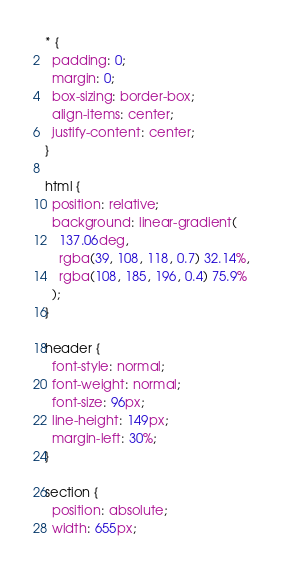Convert code to text. <code><loc_0><loc_0><loc_500><loc_500><_CSS_>* {
  padding: 0;
  margin: 0;
  box-sizing: border-box;
  align-items: center;
  justify-content: center;
}

html {
  position: relative;
  background: linear-gradient(
    137.06deg,
    rgba(39, 108, 118, 0.7) 32.14%,
    rgba(108, 185, 196, 0.4) 75.9%
  );
}

header {
  font-style: normal;
  font-weight: normal;
  font-size: 96px;
  line-height: 149px;
  margin-left: 30%;
}

section {
  position: absolute;
  width: 655px;</code> 